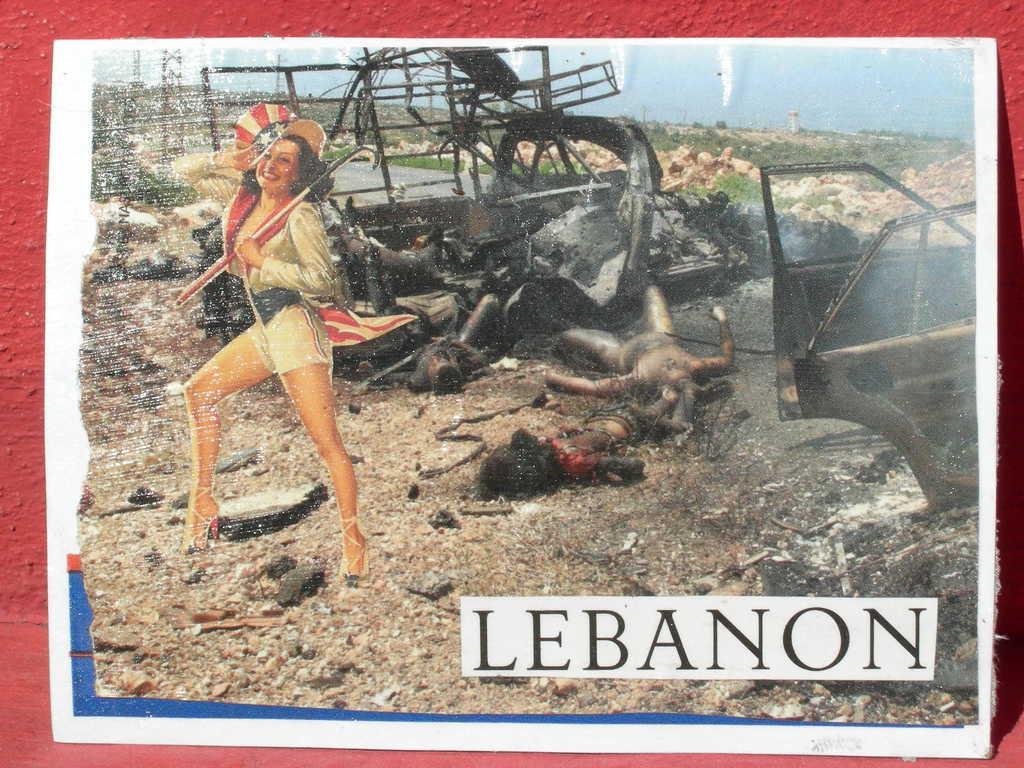Could you give a brief overview of what you see in this image? In this image we can see the photograph of a woman holding the stick. We can also see the burned out cars, bodies and also stones, sky, grass and text and the photograph is placed on the red color surface. 